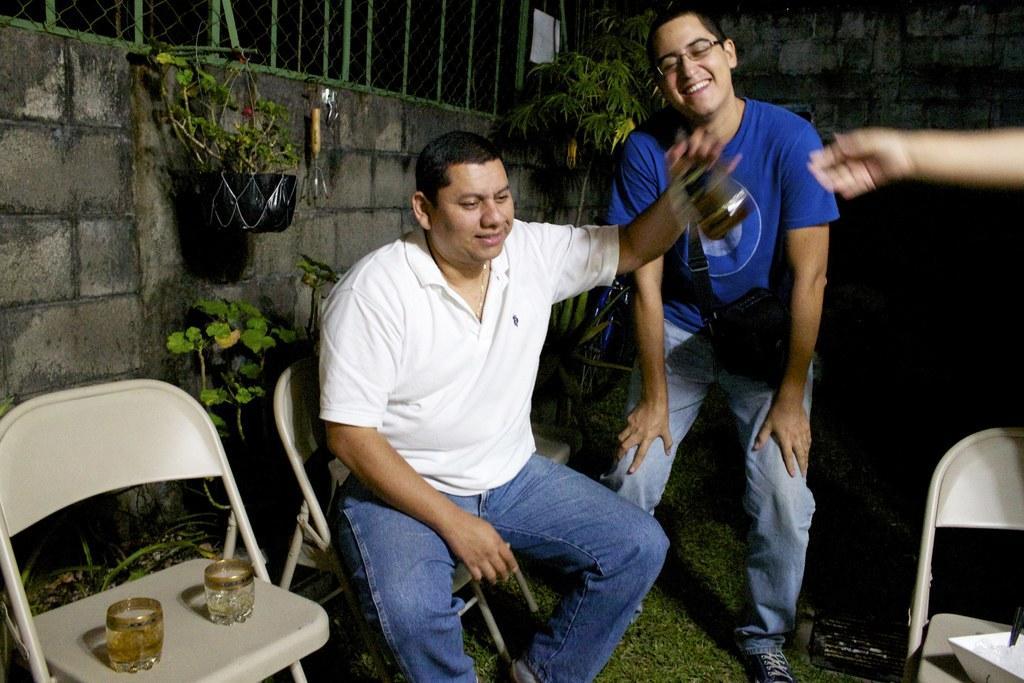Could you give a brief overview of what you see in this image? In this image there is a man sitting in chair , another man standing and smiling beside him ,at the back ground there are chairs, glasses, plants, net , tree, iron grills, grass. 